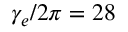Convert formula to latex. <formula><loc_0><loc_0><loc_500><loc_500>\gamma _ { e } / 2 \pi = 2 8</formula> 